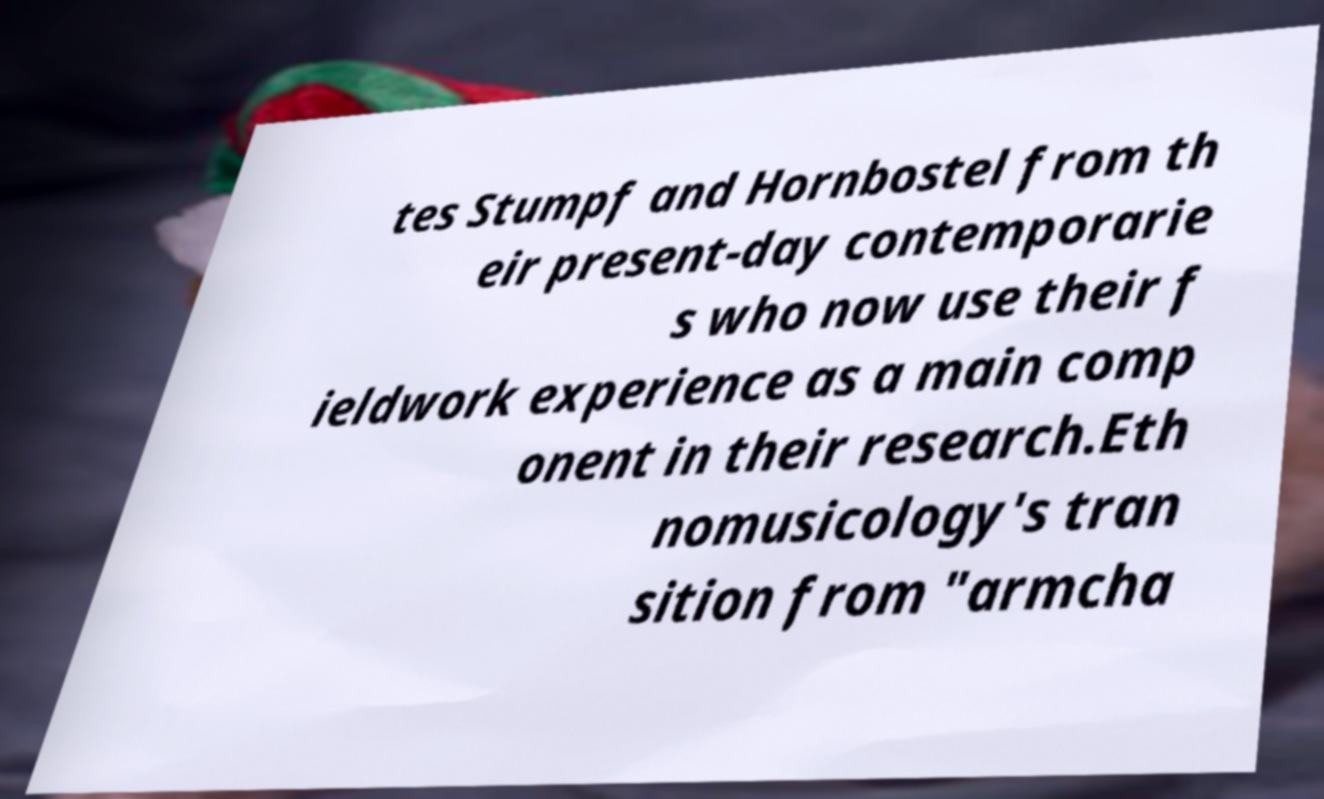I need the written content from this picture converted into text. Can you do that? tes Stumpf and Hornbostel from th eir present-day contemporarie s who now use their f ieldwork experience as a main comp onent in their research.Eth nomusicology's tran sition from "armcha 